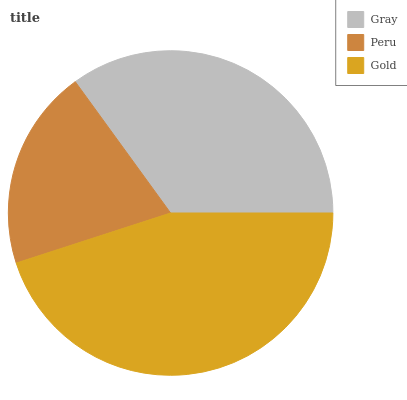Is Peru the minimum?
Answer yes or no. Yes. Is Gold the maximum?
Answer yes or no. Yes. Is Gold the minimum?
Answer yes or no. No. Is Peru the maximum?
Answer yes or no. No. Is Gold greater than Peru?
Answer yes or no. Yes. Is Peru less than Gold?
Answer yes or no. Yes. Is Peru greater than Gold?
Answer yes or no. No. Is Gold less than Peru?
Answer yes or no. No. Is Gray the high median?
Answer yes or no. Yes. Is Gray the low median?
Answer yes or no. Yes. Is Peru the high median?
Answer yes or no. No. Is Peru the low median?
Answer yes or no. No. 